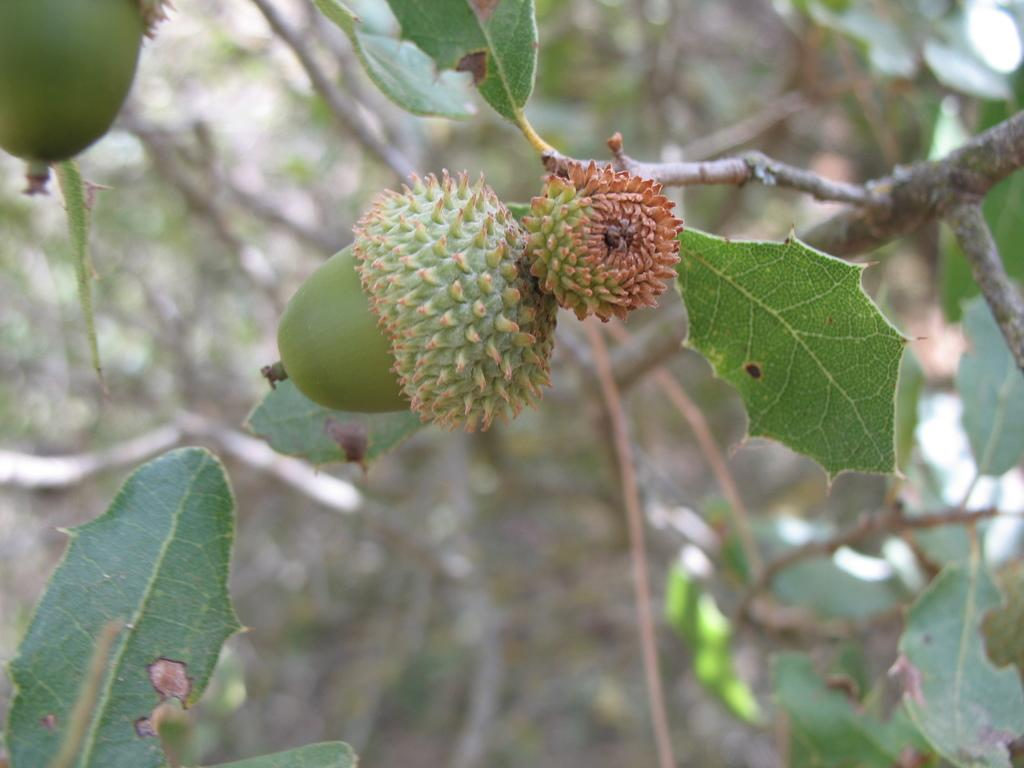What type of fruit can be seen on a tree in the image? There is a soursop on a tree in the image. What else is visible in the image besides the soursop? There are leaves visible in the image. What type of holiday is being celebrated in the image? There is no indication of a holiday being celebrated in the image; it features a soursop on a tree and leaves. Can you see any feathers on the soursop or leaves in the image? There are no feathers visible in the image. 